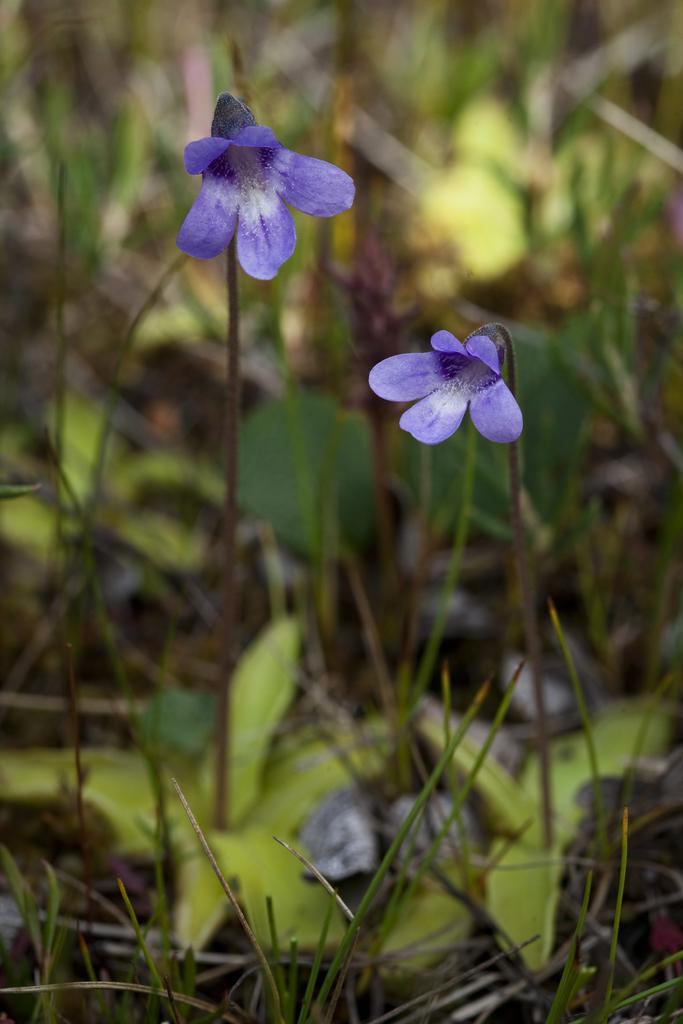Please provide a concise description of this image. In this picture we can see flowers and plants, also we can see blurry background. 